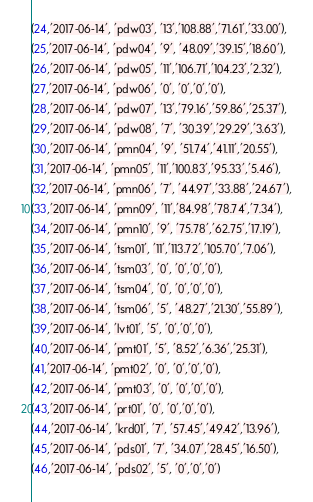<code> <loc_0><loc_0><loc_500><loc_500><_SQL_>(24,'2017-06-14', 'pdw03', '13','108.88','71.61','33.00'),
(25,'2017-06-14', 'pdw04', '9', '48.09','39.15','18.60'),
(26,'2017-06-14', 'pdw05', '11','106.71','104.23','2.32'),
(27,'2017-06-14', 'pdw06', '0', '0','0','0'),
(28,'2017-06-14', 'pdw07', '13','79.16','59.86','25.37'),
(29,'2017-06-14', 'pdw08', '7', '30.39','29.29','3.63'),
(30,'2017-06-14', 'pmn04', '9', '51.74','41.11','20.55'),
(31,'2017-06-14', 'pmn05', '11','100.83','95.33','5.46'),
(32,'2017-06-14', 'pmn06', '7', '44.97','33.88','24.67'),
(33,'2017-06-14', 'pmn09', '11','84.98','78.74','7.34'),
(34,'2017-06-14', 'pmn10', '9', '75.78','62.75','17.19'),
(35,'2017-06-14', 'tsm01', '11','113.72','105.70','7.06'),
(36,'2017-06-14', 'tsm03', '0', '0','0','0'),
(37,'2017-06-14', 'tsm04', '0', '0','0','0'),
(38,'2017-06-14', 'tsm06', '5', '48.27','21.30','55.89'),
(39,'2017-06-14', 'lvt01', '5', '0','0','0'),
(40,'2017-06-14', 'pmt01', '5', '8.52','6.36','25.31'),
(41,'2017-06-14', 'pmt02', '0', '0','0','0'),
(42,'2017-06-14', 'pmt03', '0', '0','0','0'),
(43,'2017-06-14', 'prt01', '0', '0','0','0'),
(44,'2017-06-14', 'krd01', '7', '57.45','49.42','13.96'),
(45,'2017-06-14', 'pds01', '7', '34.07','28.45','16.50'),
(46,'2017-06-14', 'pds02', '5', '0','0','0')
</code> 